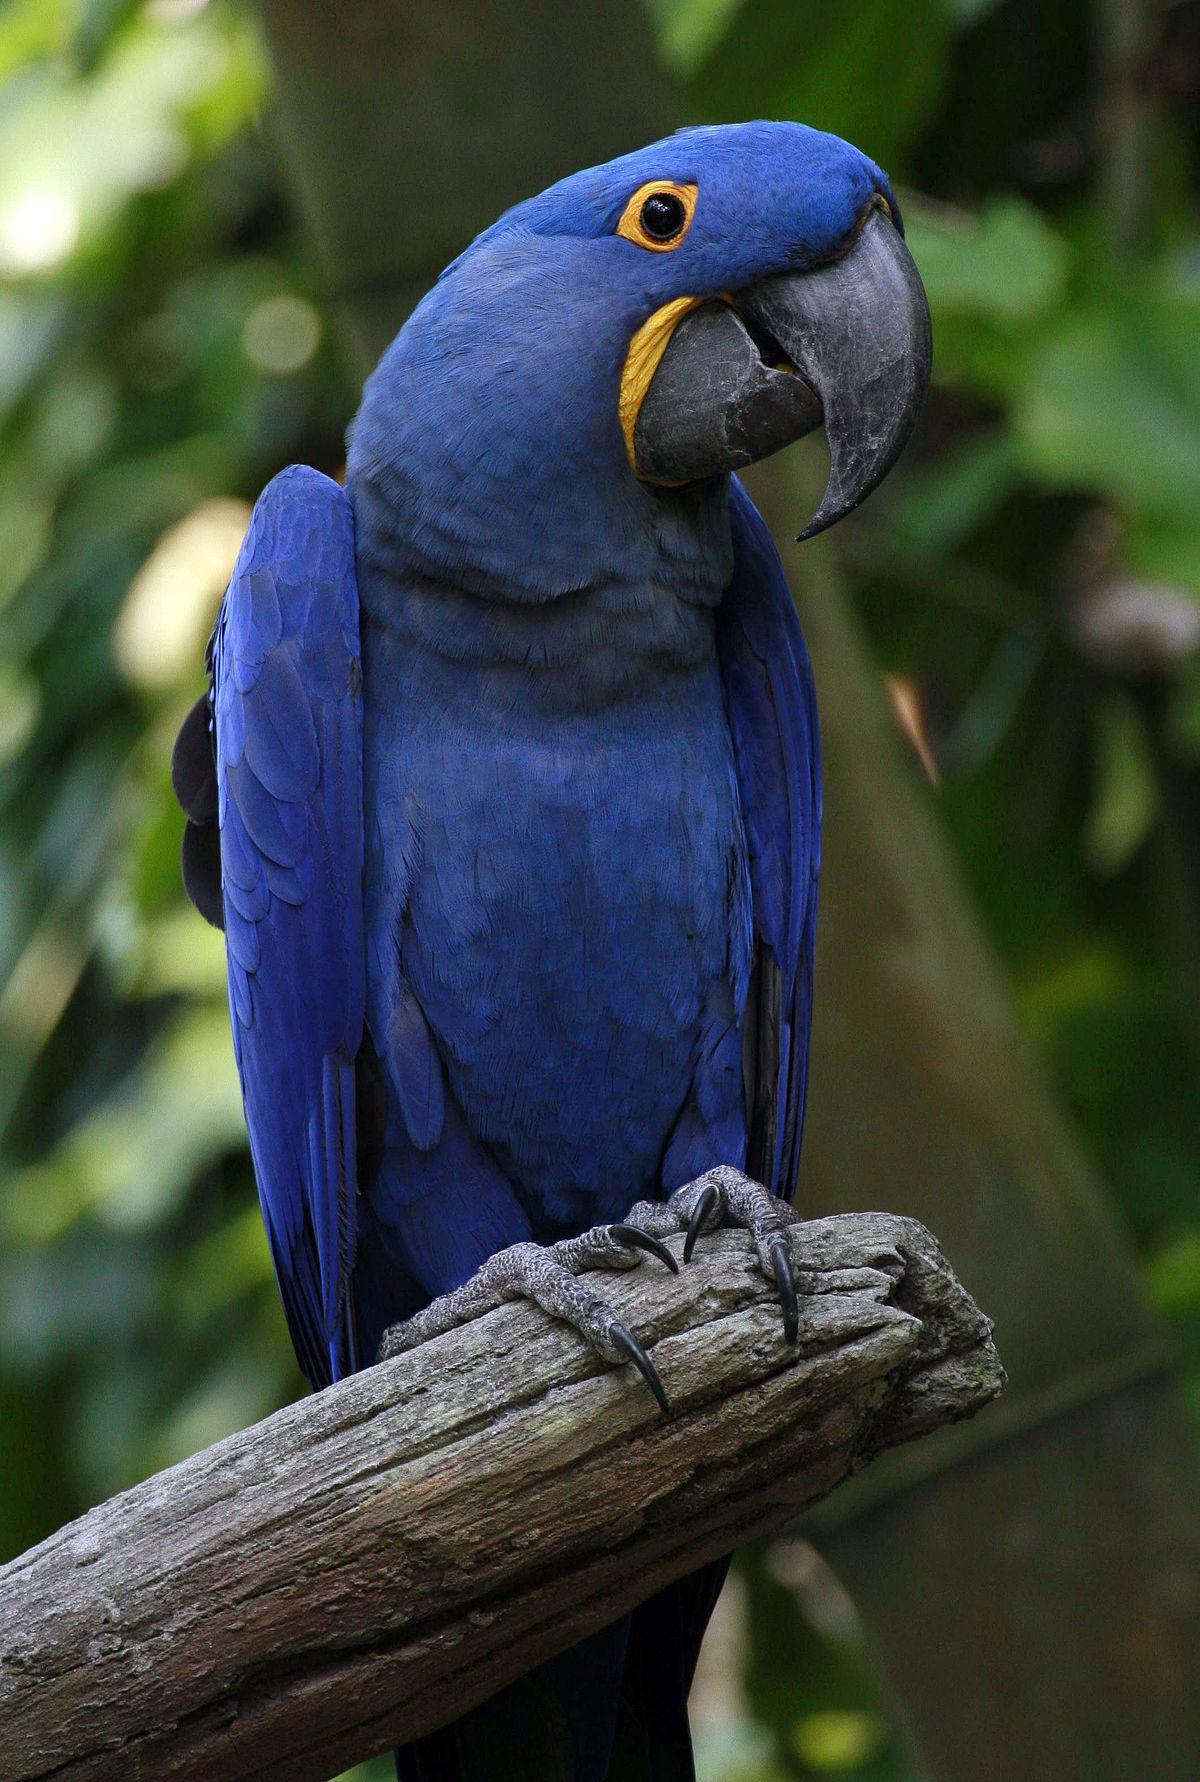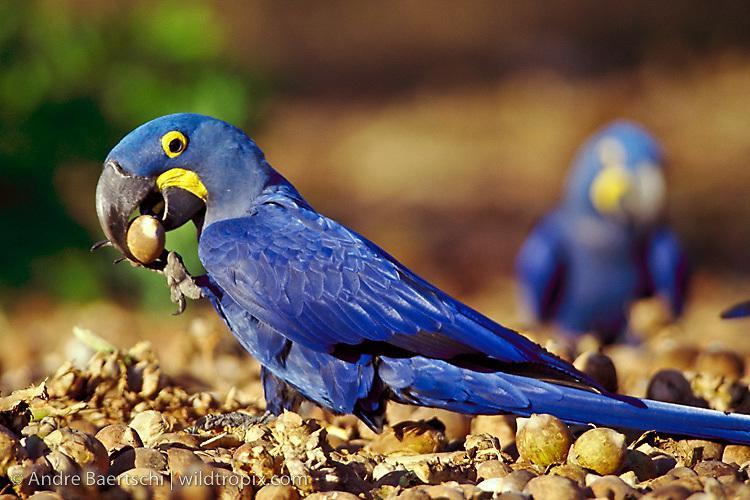The first image is the image on the left, the second image is the image on the right. For the images displayed, is the sentence "There are three parrots." factually correct? Answer yes or no. Yes. 